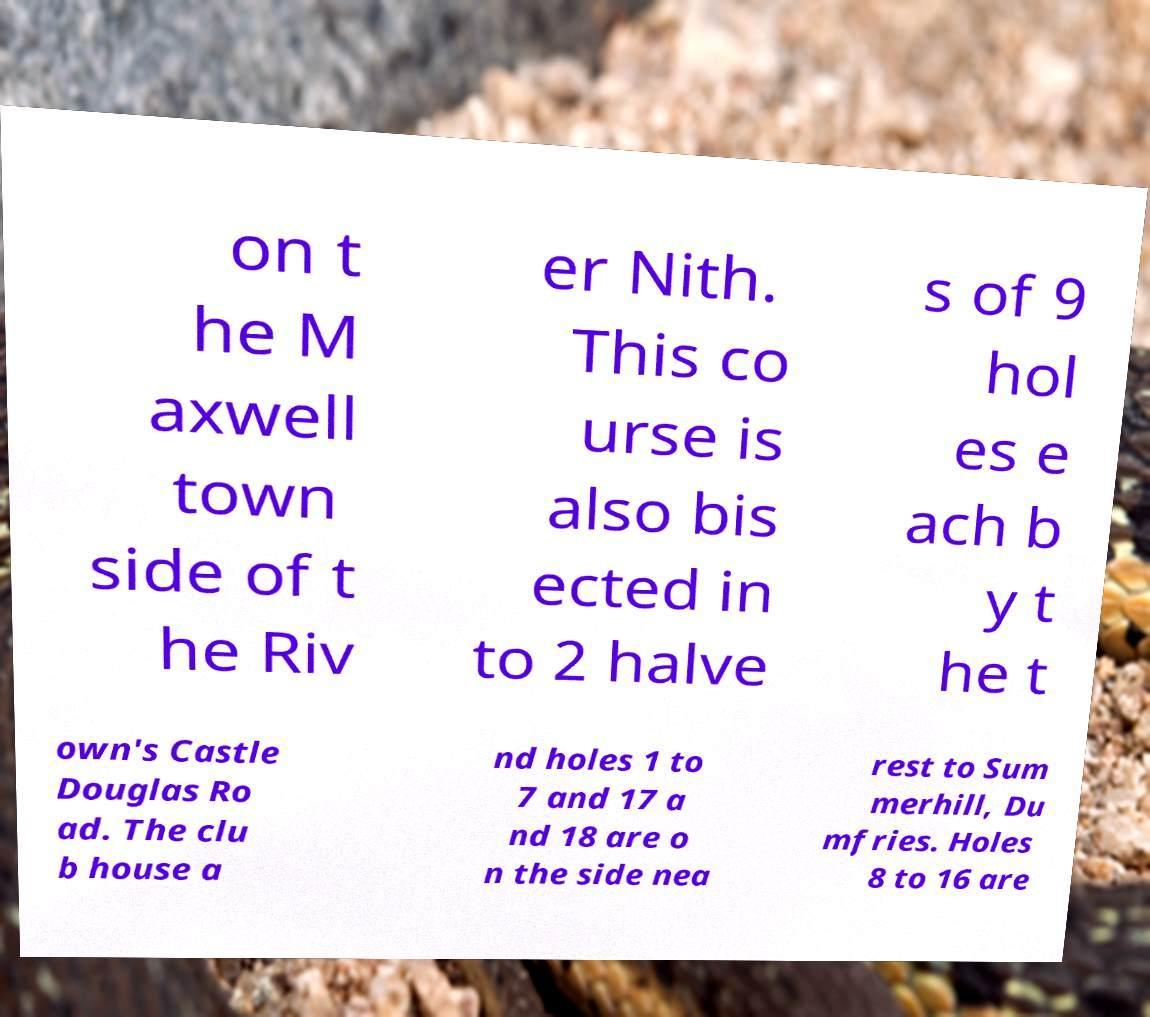Can you read and provide the text displayed in the image?This photo seems to have some interesting text. Can you extract and type it out for me? on t he M axwell town side of t he Riv er Nith. This co urse is also bis ected in to 2 halve s of 9 hol es e ach b y t he t own's Castle Douglas Ro ad. The clu b house a nd holes 1 to 7 and 17 a nd 18 are o n the side nea rest to Sum merhill, Du mfries. Holes 8 to 16 are 